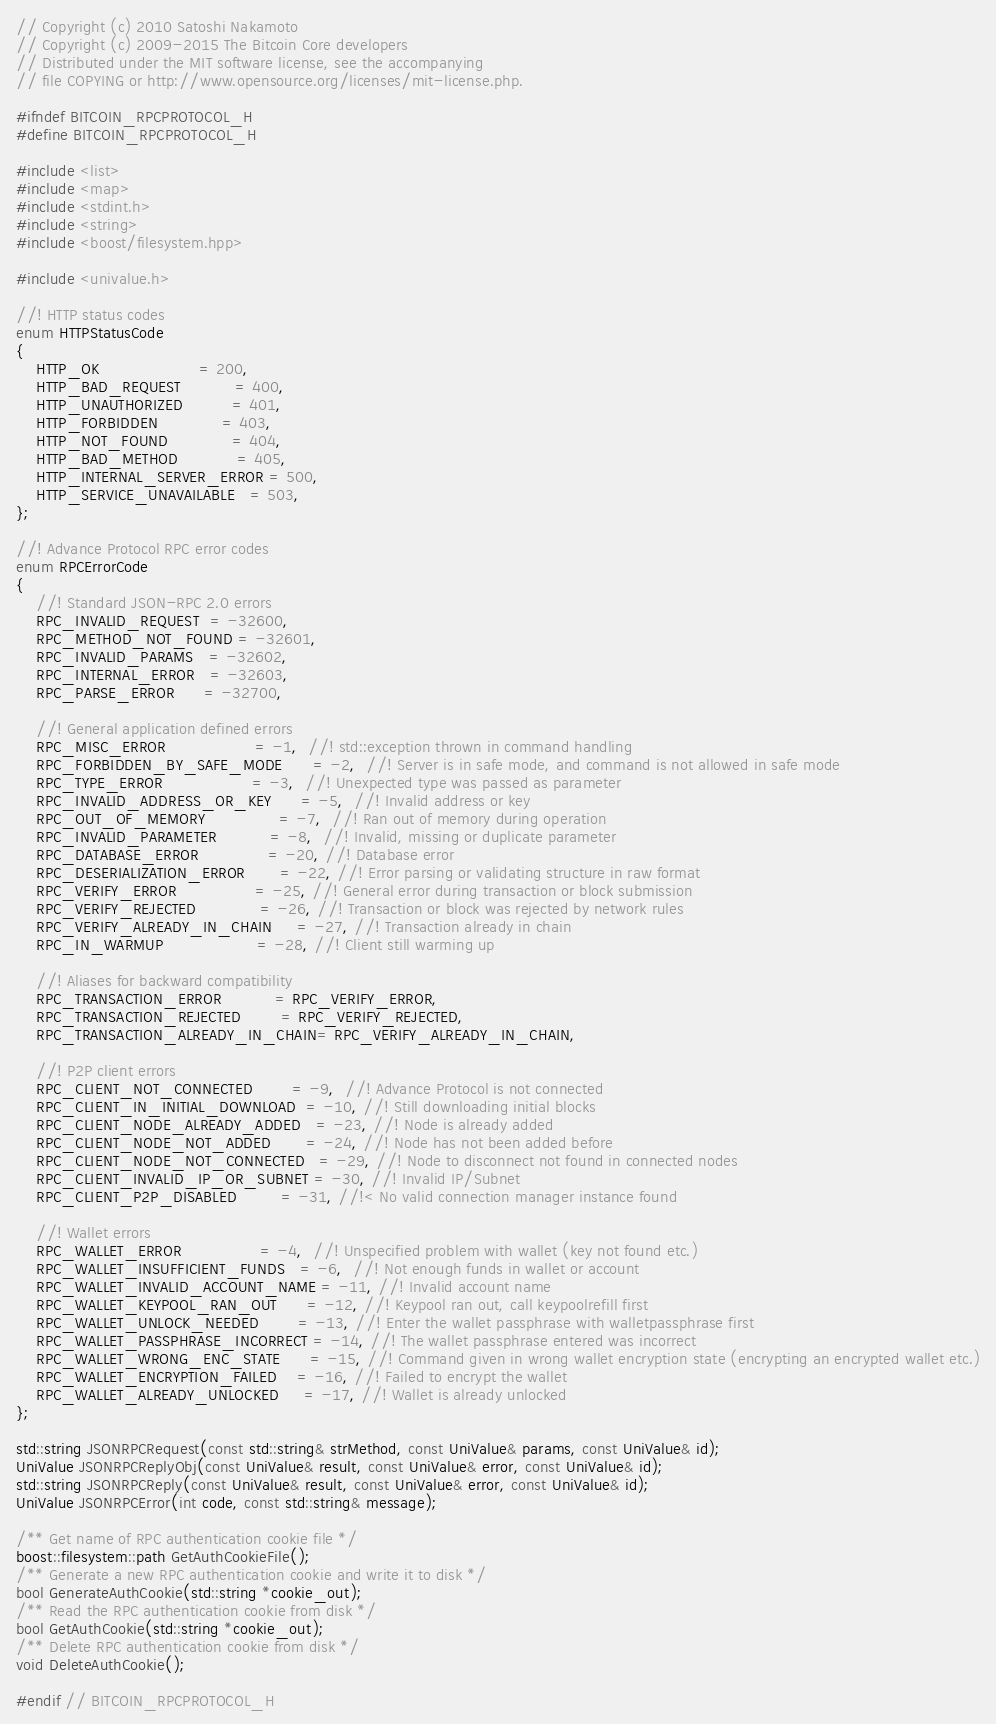Convert code to text. <code><loc_0><loc_0><loc_500><loc_500><_C_>// Copyright (c) 2010 Satoshi Nakamoto
// Copyright (c) 2009-2015 The Bitcoin Core developers
// Distributed under the MIT software license, see the accompanying
// file COPYING or http://www.opensource.org/licenses/mit-license.php.

#ifndef BITCOIN_RPCPROTOCOL_H
#define BITCOIN_RPCPROTOCOL_H

#include <list>
#include <map>
#include <stdint.h>
#include <string>
#include <boost/filesystem.hpp>

#include <univalue.h>

//! HTTP status codes
enum HTTPStatusCode
{
    HTTP_OK                    = 200,
    HTTP_BAD_REQUEST           = 400,
    HTTP_UNAUTHORIZED          = 401,
    HTTP_FORBIDDEN             = 403,
    HTTP_NOT_FOUND             = 404,
    HTTP_BAD_METHOD            = 405,
    HTTP_INTERNAL_SERVER_ERROR = 500,
    HTTP_SERVICE_UNAVAILABLE   = 503,
};

//! Advance Protocol RPC error codes
enum RPCErrorCode
{
    //! Standard JSON-RPC 2.0 errors
    RPC_INVALID_REQUEST  = -32600,
    RPC_METHOD_NOT_FOUND = -32601,
    RPC_INVALID_PARAMS   = -32602,
    RPC_INTERNAL_ERROR   = -32603,
    RPC_PARSE_ERROR      = -32700,

    //! General application defined errors
    RPC_MISC_ERROR                  = -1,  //! std::exception thrown in command handling
    RPC_FORBIDDEN_BY_SAFE_MODE      = -2,  //! Server is in safe mode, and command is not allowed in safe mode
    RPC_TYPE_ERROR                  = -3,  //! Unexpected type was passed as parameter
    RPC_INVALID_ADDRESS_OR_KEY      = -5,  //! Invalid address or key
    RPC_OUT_OF_MEMORY               = -7,  //! Ran out of memory during operation
    RPC_INVALID_PARAMETER           = -8,  //! Invalid, missing or duplicate parameter
    RPC_DATABASE_ERROR              = -20, //! Database error
    RPC_DESERIALIZATION_ERROR       = -22, //! Error parsing or validating structure in raw format
    RPC_VERIFY_ERROR                = -25, //! General error during transaction or block submission
    RPC_VERIFY_REJECTED             = -26, //! Transaction or block was rejected by network rules
    RPC_VERIFY_ALREADY_IN_CHAIN     = -27, //! Transaction already in chain
    RPC_IN_WARMUP                   = -28, //! Client still warming up

    //! Aliases for backward compatibility
    RPC_TRANSACTION_ERROR           = RPC_VERIFY_ERROR,
    RPC_TRANSACTION_REJECTED        = RPC_VERIFY_REJECTED,
    RPC_TRANSACTION_ALREADY_IN_CHAIN= RPC_VERIFY_ALREADY_IN_CHAIN,

    //! P2P client errors
    RPC_CLIENT_NOT_CONNECTED        = -9,  //! Advance Protocol is not connected
    RPC_CLIENT_IN_INITIAL_DOWNLOAD  = -10, //! Still downloading initial blocks
    RPC_CLIENT_NODE_ALREADY_ADDED   = -23, //! Node is already added
    RPC_CLIENT_NODE_NOT_ADDED       = -24, //! Node has not been added before
    RPC_CLIENT_NODE_NOT_CONNECTED   = -29, //! Node to disconnect not found in connected nodes
    RPC_CLIENT_INVALID_IP_OR_SUBNET = -30, //! Invalid IP/Subnet
    RPC_CLIENT_P2P_DISABLED         = -31, //!< No valid connection manager instance found

    //! Wallet errors
    RPC_WALLET_ERROR                = -4,  //! Unspecified problem with wallet (key not found etc.)
    RPC_WALLET_INSUFFICIENT_FUNDS   = -6,  //! Not enough funds in wallet or account
    RPC_WALLET_INVALID_ACCOUNT_NAME = -11, //! Invalid account name
    RPC_WALLET_KEYPOOL_RAN_OUT      = -12, //! Keypool ran out, call keypoolrefill first
    RPC_WALLET_UNLOCK_NEEDED        = -13, //! Enter the wallet passphrase with walletpassphrase first
    RPC_WALLET_PASSPHRASE_INCORRECT = -14, //! The wallet passphrase entered was incorrect
    RPC_WALLET_WRONG_ENC_STATE      = -15, //! Command given in wrong wallet encryption state (encrypting an encrypted wallet etc.)
    RPC_WALLET_ENCRYPTION_FAILED    = -16, //! Failed to encrypt the wallet
    RPC_WALLET_ALREADY_UNLOCKED     = -17, //! Wallet is already unlocked
};

std::string JSONRPCRequest(const std::string& strMethod, const UniValue& params, const UniValue& id);
UniValue JSONRPCReplyObj(const UniValue& result, const UniValue& error, const UniValue& id);
std::string JSONRPCReply(const UniValue& result, const UniValue& error, const UniValue& id);
UniValue JSONRPCError(int code, const std::string& message);

/** Get name of RPC authentication cookie file */
boost::filesystem::path GetAuthCookieFile();
/** Generate a new RPC authentication cookie and write it to disk */
bool GenerateAuthCookie(std::string *cookie_out);
/** Read the RPC authentication cookie from disk */
bool GetAuthCookie(std::string *cookie_out);
/** Delete RPC authentication cookie from disk */
void DeleteAuthCookie();

#endif // BITCOIN_RPCPROTOCOL_H
</code> 